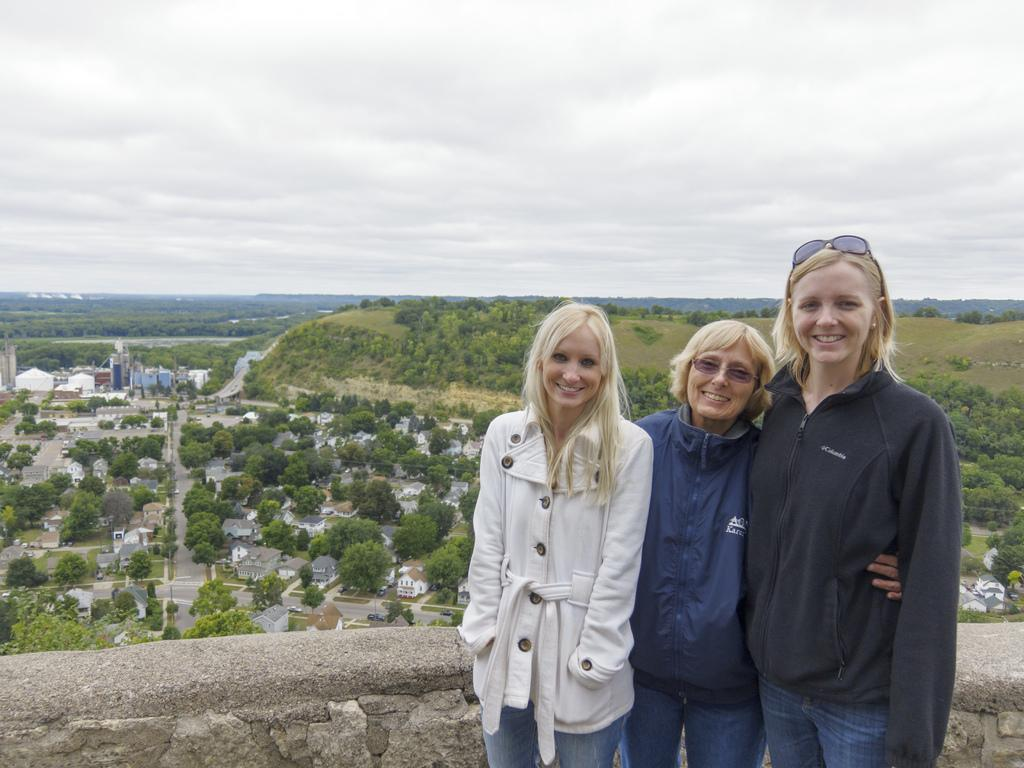How many women are in the image? There are three women in the image. What are the women doing in the image? The women are standing and smiling. What can be seen in the background of the image? There are trees, buildings, a road, and the sky visible in the background of the image. What is the condition of the sky in the image? Clouds are present in the sky. What type of question is being asked by the fireman in the image? There is no fireman present in the image, so it is not possible to answer that question. 